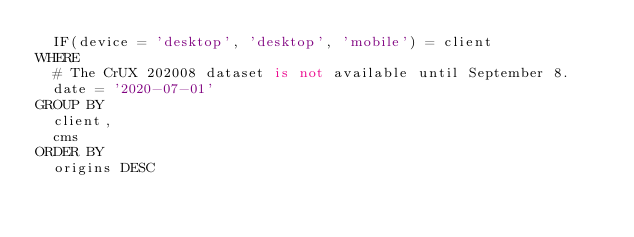Convert code to text. <code><loc_0><loc_0><loc_500><loc_500><_SQL_>  IF(device = 'desktop', 'desktop', 'mobile') = client
WHERE
  # The CrUX 202008 dataset is not available until September 8.
  date = '2020-07-01'
GROUP BY
  client,
  cms
ORDER BY
  origins DESC
</code> 